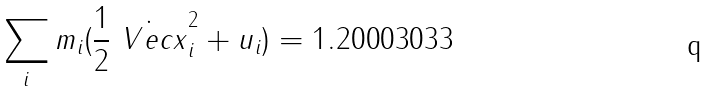Convert formula to latex. <formula><loc_0><loc_0><loc_500><loc_500>\sum _ { i } m _ { i } ( \frac { 1 } { 2 } \dot { \ V e c { x } } _ { i } ^ { 2 } + u _ { i } ) = 1 . 2 0 0 0 3 0 3 3</formula> 